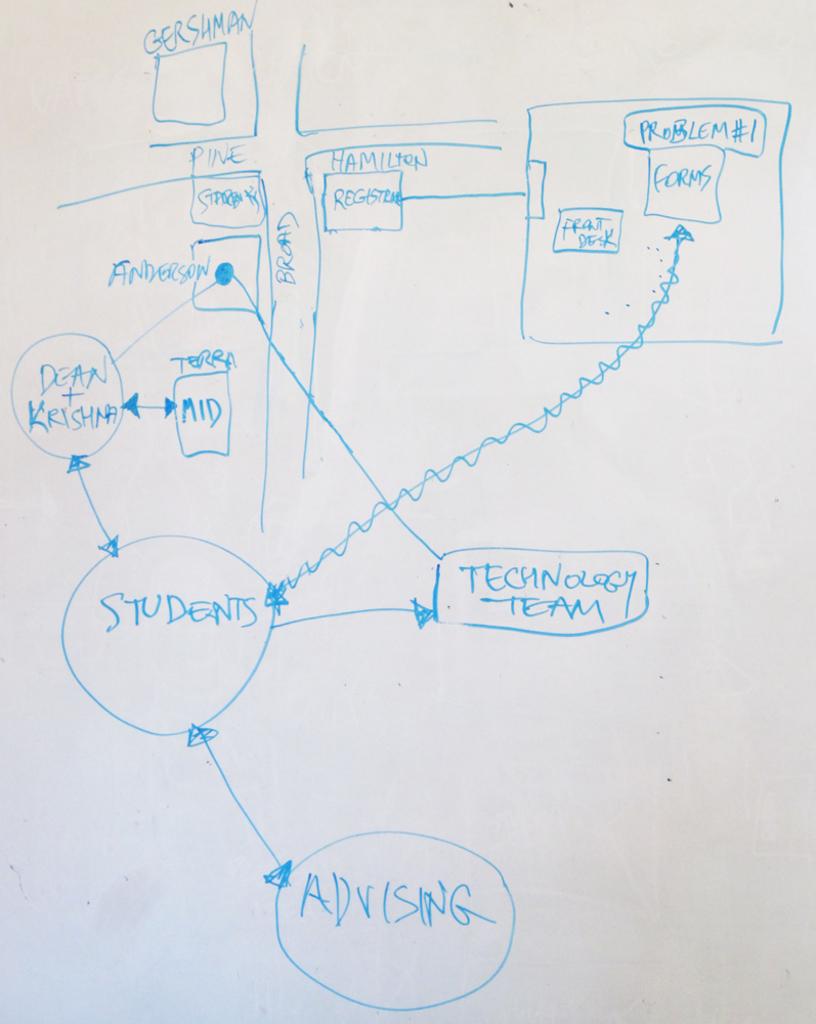Who is in the middle circle?
Provide a short and direct response. Students. What does the bottom most circle read?
Your answer should be compact. Advising. 